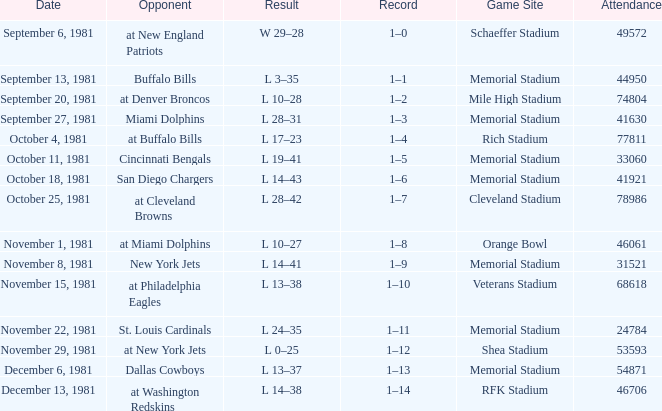When it is week 2 what is the record? 1–1. 